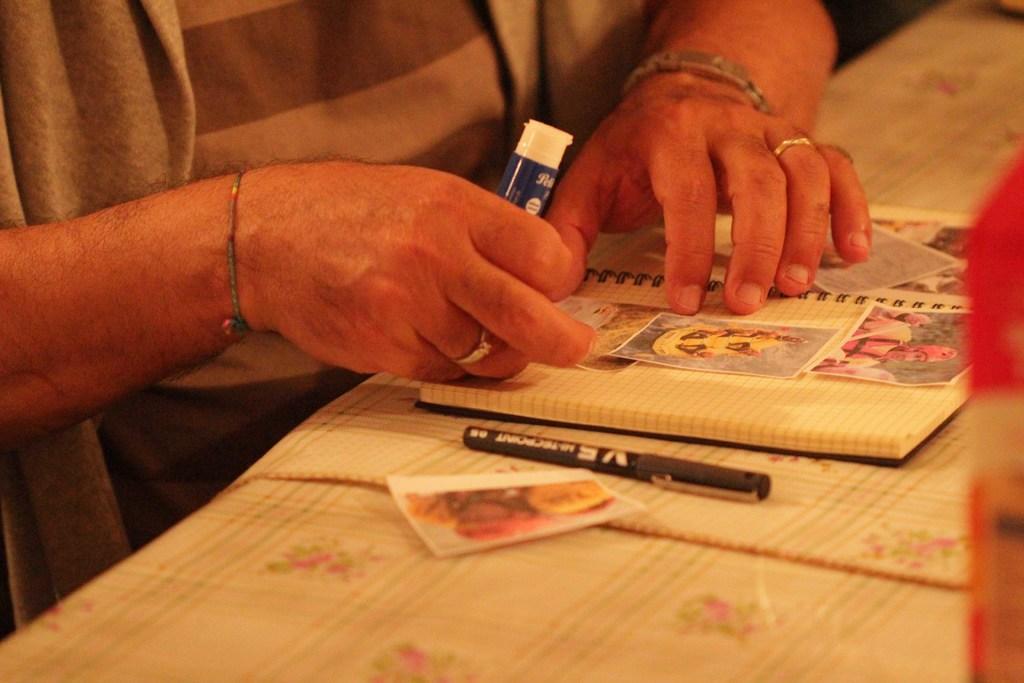In one or two sentences, can you explain what this image depicts? In this image we can see a person sitting holding a glue stick. We can also see a table in front of him containing a paper, pen and a book with some pictures pasted in it. On the right side we can see an object. 